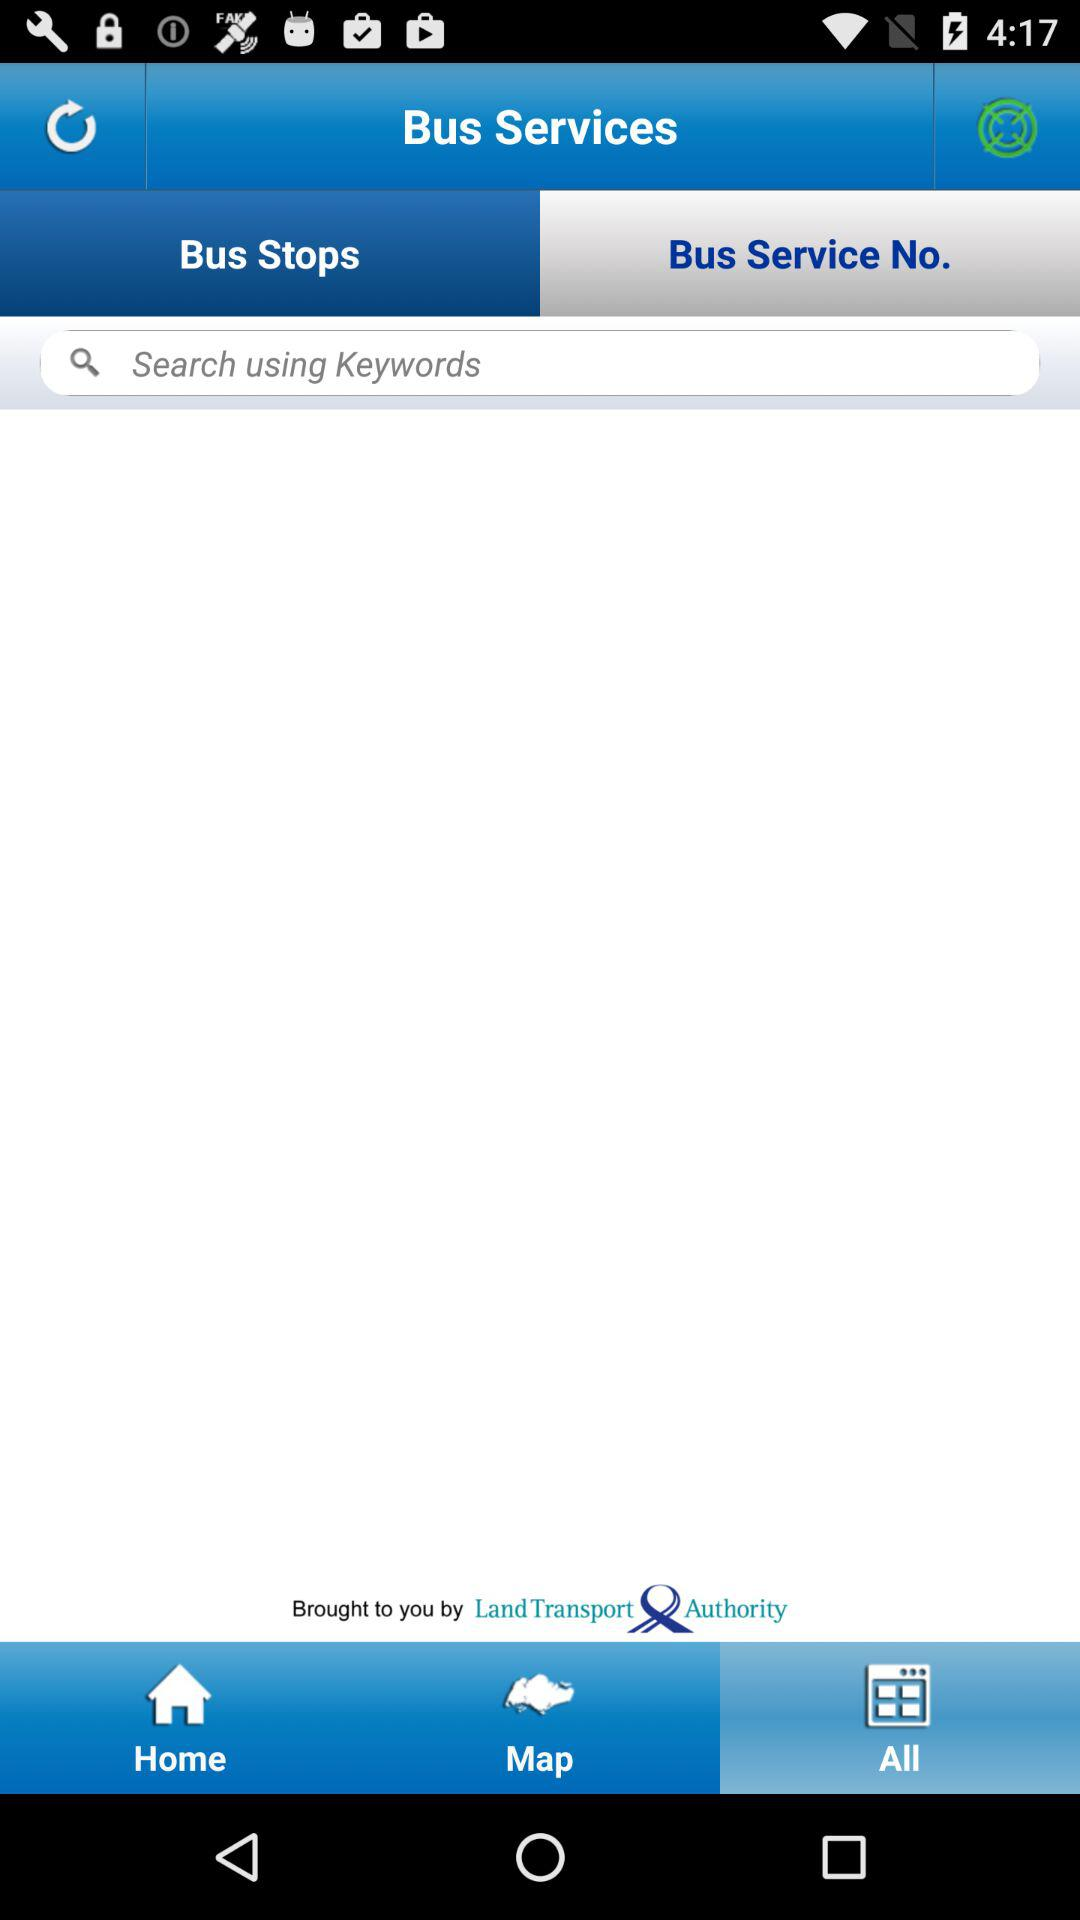Which tab is currently selected at the top? The tab "Bus Service No." is currently selected at the top. 